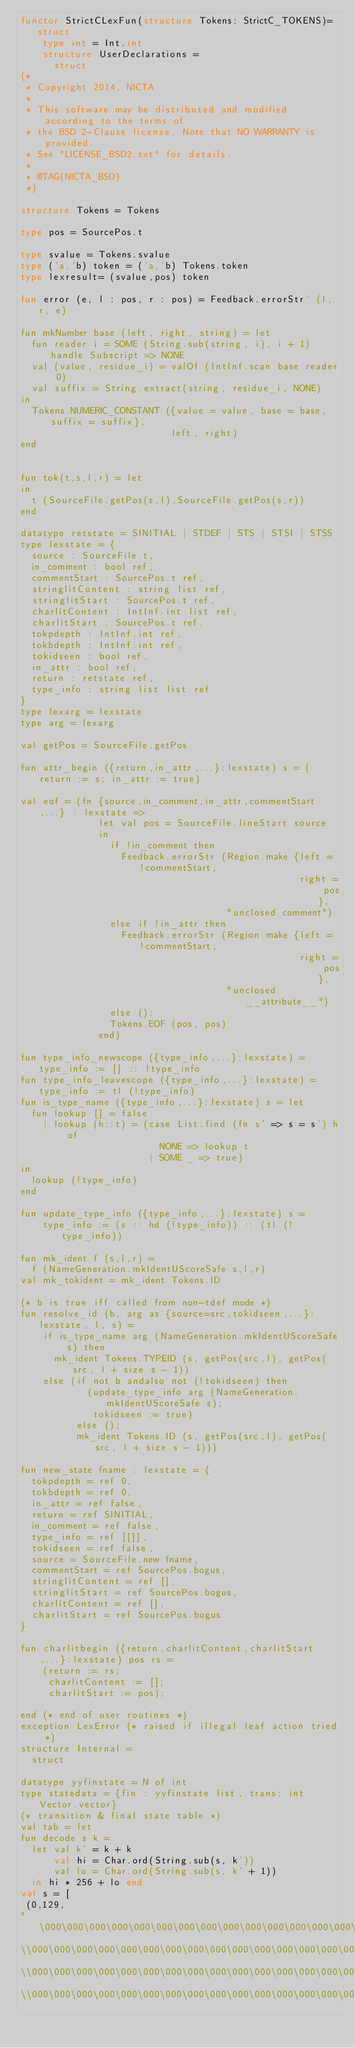Convert code to text. <code><loc_0><loc_0><loc_500><loc_500><_SML_>functor StrictCLexFun(structure Tokens: StrictC_TOKENS)=
   struct
    type int = Int.int
    structure UserDeclarations =
      struct
(*
 * Copyright 2014, NICTA
 *
 * This software may be distributed and modified according to the terms of
 * the BSD 2-Clause license. Note that NO WARRANTY is provided.
 * See "LICENSE_BSD2.txt" for details.
 *
 * @TAG(NICTA_BSD)
 *)

structure Tokens = Tokens

type pos = SourcePos.t

type svalue = Tokens.svalue
type ('a,'b) token = ('a,'b) Tokens.token
type lexresult= (svalue,pos) token

fun error (e, l : pos, r : pos) = Feedback.errorStr' (l, r, e)

fun mkNumber base (left, right, string) = let
  fun reader i = SOME (String.sub(string, i), i + 1) handle Subscript => NONE
  val (value, residue_i) = valOf (IntInf.scan base reader 0)
  val suffix = String.extract(string, residue_i, NONE)
in
  Tokens.NUMERIC_CONSTANT ({value = value, base = base, suffix = suffix},
                           left, right)
end


fun tok(t,s,l,r) = let
in
  t (SourceFile.getPos(s,l),SourceFile.getPos(s,r))
end

datatype retstate = SINITIAL | STDEF | STS | STSI | STSS
type lexstate = {
  source : SourceFile.t,
  in_comment : bool ref,
  commentStart : SourcePos.t ref,
  stringlitContent : string list ref,
  stringlitStart : SourcePos.t ref,
  charlitContent : IntInf.int list ref,
  charlitStart : SourcePos.t ref,
  tokpdepth : IntInf.int ref,
  tokbdepth : IntInf.int ref,
  tokidseen : bool ref,
  in_attr : bool ref,
  return : retstate ref,
  type_info : string list list ref
}
type lexarg = lexstate
type arg = lexarg

val getPos = SourceFile.getPos

fun attr_begin ({return,in_attr,...}:lexstate) s = (return := s; in_attr := true)

val eof = (fn {source,in_comment,in_attr,commentStart,...} : lexstate =>
              let val pos = SourceFile.lineStart source
              in
                if !in_comment then
                  Feedback.errorStr (Region.make {left = !commentStart,
                                                  right = pos},
                                     "unclosed comment")
                else if !in_attr then
                  Feedback.errorStr (Region.make {left = !commentStart,
                                                  right = pos},
                                     "unclosed __attribute__")
                else ();
                Tokens.EOF (pos, pos)
              end)

fun type_info_newscope ({type_info,...}:lexstate) = type_info := [] :: !type_info
fun type_info_leavescope ({type_info,...}:lexstate) = type_info := tl (!type_info)
fun is_type_name ({type_info,...}:lexstate) s = let
  fun lookup [] = false
    | lookup (h::t) = (case List.find (fn s' => s = s') h of
                         NONE => lookup t
                       | SOME _ => true)
in
  lookup (!type_info)
end

fun update_type_info ({type_info,...}:lexstate) s =
    type_info := (s :: hd (!type_info)) :: (tl (!type_info))

fun mk_ident f (s,l,r) =
  f (NameGeneration.mkIdentUScoreSafe s,l,r)
val mk_tokident = mk_ident Tokens.ID

(* b is true iff called from non-tdef mode *)
fun resolve_id (b, arg as {source=src,tokidseen,...}:lexstate, l, s) =
    if is_type_name arg (NameGeneration.mkIdentUScoreSafe s) then
      mk_ident Tokens.TYPEID (s, getPos(src,l), getPos(src, l + size s - 1))
    else (if not b andalso not (!tokidseen) then
            (update_type_info arg (NameGeneration.mkIdentUScoreSafe s);
             tokidseen := true)
          else ();
          mk_ident Tokens.ID (s, getPos(src,l), getPos(src, l + size s - 1)))

fun new_state fname : lexstate = {
  tokpdepth = ref 0,
  tokbdepth = ref 0,
  in_attr = ref false,
  return = ref SINITIAL,
  in_comment = ref false,
  type_info = ref [[]],
  tokidseen = ref false,
  source = SourceFile.new fname,
  commentStart = ref SourcePos.bogus,
  stringlitContent = ref [],
  stringlitStart = ref SourcePos.bogus,
  charlitContent = ref [],
  charlitStart = ref SourcePos.bogus
}

fun charlitbegin ({return,charlitContent,charlitStart,...}:lexstate) pos rs =
    (return := rs;
     charlitContent := [];
     charlitStart := pos);

end (* end of user routines *)
exception LexError (* raised if illegal leaf action tried *)
structure Internal =
	struct

datatype yyfinstate = N of int
type statedata = {fin : yyfinstate list, trans: int Vector.vector}
(* transition & final state table *)
val tab = let
fun decode s k =
  let val k' = k + k
      val hi = Char.ord(String.sub(s, k'))
      val lo = Char.ord(String.sub(s, k' + 1))
  in hi * 256 + lo end
val s = [
 (0,129,
"\000\000\000\000\000\000\000\000\000\000\000\000\000\000\000\000\
\\000\000\000\000\000\000\000\000\000\000\000\000\000\000\000\000\
\\000\000\000\000\000\000\000\000\000\000\000\000\000\000\000\000\
\\000\000\000\000\000\000\000\000\000\000\000\000\000\000\000\000\</code> 